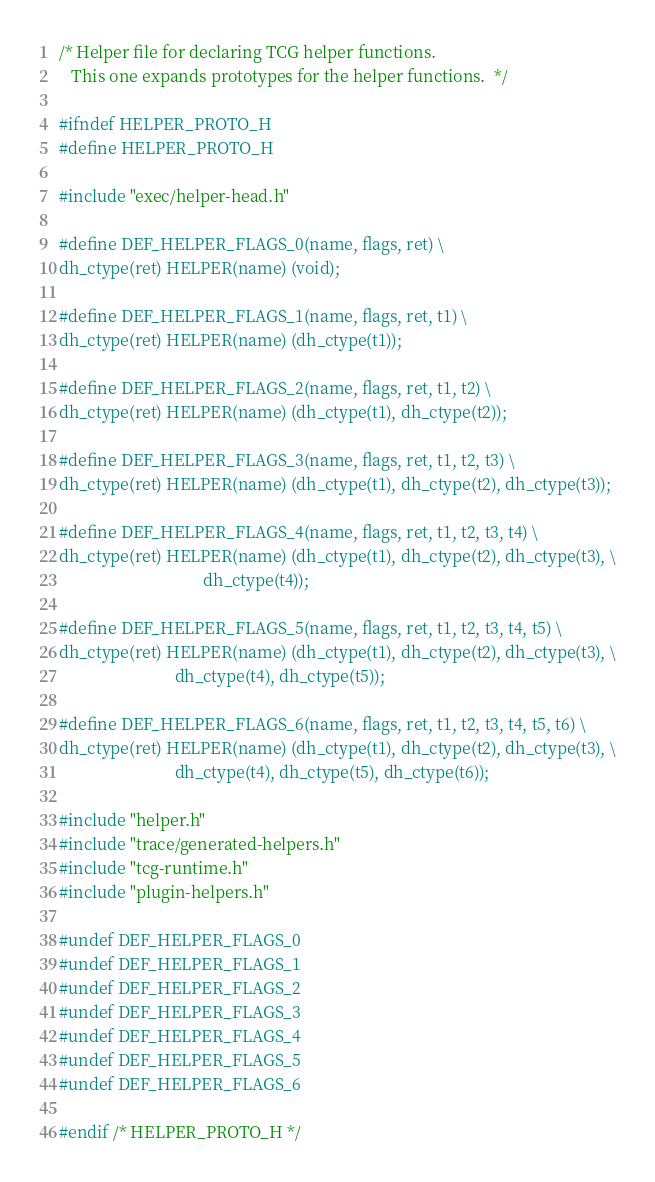Convert code to text. <code><loc_0><loc_0><loc_500><loc_500><_C_>/* Helper file for declaring TCG helper functions.
   This one expands prototypes for the helper functions.  */

#ifndef HELPER_PROTO_H
#define HELPER_PROTO_H

#include "exec/helper-head.h"

#define DEF_HELPER_FLAGS_0(name, flags, ret) \
dh_ctype(ret) HELPER(name) (void);

#define DEF_HELPER_FLAGS_1(name, flags, ret, t1) \
dh_ctype(ret) HELPER(name) (dh_ctype(t1));

#define DEF_HELPER_FLAGS_2(name, flags, ret, t1, t2) \
dh_ctype(ret) HELPER(name) (dh_ctype(t1), dh_ctype(t2));

#define DEF_HELPER_FLAGS_3(name, flags, ret, t1, t2, t3) \
dh_ctype(ret) HELPER(name) (dh_ctype(t1), dh_ctype(t2), dh_ctype(t3));

#define DEF_HELPER_FLAGS_4(name, flags, ret, t1, t2, t3, t4) \
dh_ctype(ret) HELPER(name) (dh_ctype(t1), dh_ctype(t2), dh_ctype(t3), \
                                   dh_ctype(t4));

#define DEF_HELPER_FLAGS_5(name, flags, ret, t1, t2, t3, t4, t5) \
dh_ctype(ret) HELPER(name) (dh_ctype(t1), dh_ctype(t2), dh_ctype(t3), \
                            dh_ctype(t4), dh_ctype(t5));

#define DEF_HELPER_FLAGS_6(name, flags, ret, t1, t2, t3, t4, t5, t6) \
dh_ctype(ret) HELPER(name) (dh_ctype(t1), dh_ctype(t2), dh_ctype(t3), \
                            dh_ctype(t4), dh_ctype(t5), dh_ctype(t6));

#include "helper.h"
#include "trace/generated-helpers.h"
#include "tcg-runtime.h"
#include "plugin-helpers.h"

#undef DEF_HELPER_FLAGS_0
#undef DEF_HELPER_FLAGS_1
#undef DEF_HELPER_FLAGS_2
#undef DEF_HELPER_FLAGS_3
#undef DEF_HELPER_FLAGS_4
#undef DEF_HELPER_FLAGS_5
#undef DEF_HELPER_FLAGS_6

#endif /* HELPER_PROTO_H */
</code> 